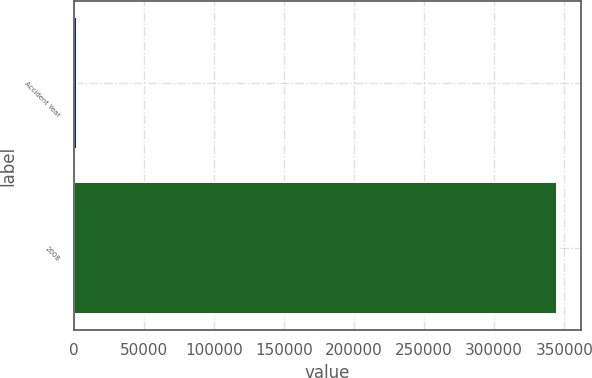Convert chart to OTSL. <chart><loc_0><loc_0><loc_500><loc_500><bar_chart><fcel>Accident Year<fcel>2008<nl><fcel>2014<fcel>344892<nl></chart> 